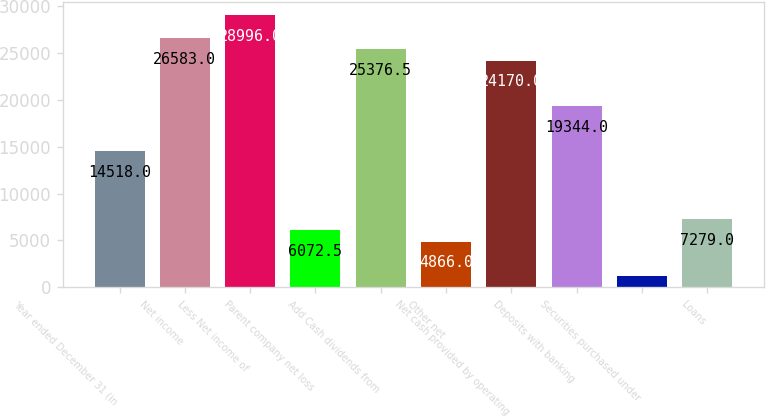Convert chart to OTSL. <chart><loc_0><loc_0><loc_500><loc_500><bar_chart><fcel>Year ended December 31 (in<fcel>Net income<fcel>Less Net income of<fcel>Parent company net loss<fcel>Add Cash dividends from<fcel>Other net<fcel>Net cash provided by operating<fcel>Deposits with banking<fcel>Securities purchased under<fcel>Loans<nl><fcel>14518<fcel>26583<fcel>28996<fcel>6072.5<fcel>25376.5<fcel>4866<fcel>24170<fcel>19344<fcel>1246.5<fcel>7279<nl></chart> 